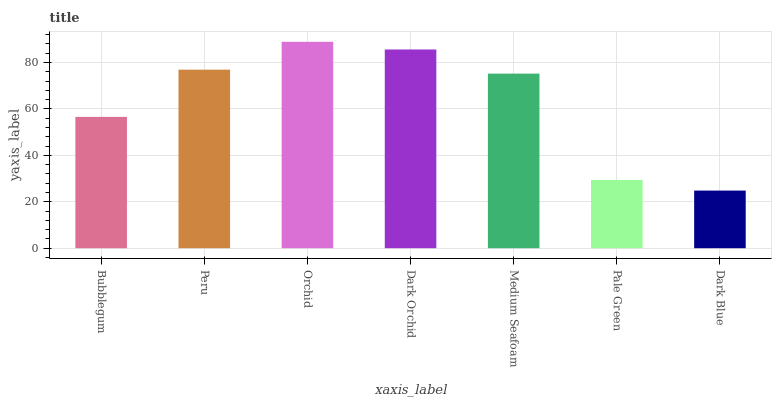Is Dark Blue the minimum?
Answer yes or no. Yes. Is Orchid the maximum?
Answer yes or no. Yes. Is Peru the minimum?
Answer yes or no. No. Is Peru the maximum?
Answer yes or no. No. Is Peru greater than Bubblegum?
Answer yes or no. Yes. Is Bubblegum less than Peru?
Answer yes or no. Yes. Is Bubblegum greater than Peru?
Answer yes or no. No. Is Peru less than Bubblegum?
Answer yes or no. No. Is Medium Seafoam the high median?
Answer yes or no. Yes. Is Medium Seafoam the low median?
Answer yes or no. Yes. Is Peru the high median?
Answer yes or no. No. Is Bubblegum the low median?
Answer yes or no. No. 